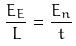<formula> <loc_0><loc_0><loc_500><loc_500>\frac { E _ { E } } { L } = \frac { E _ { n } } { t }</formula> 